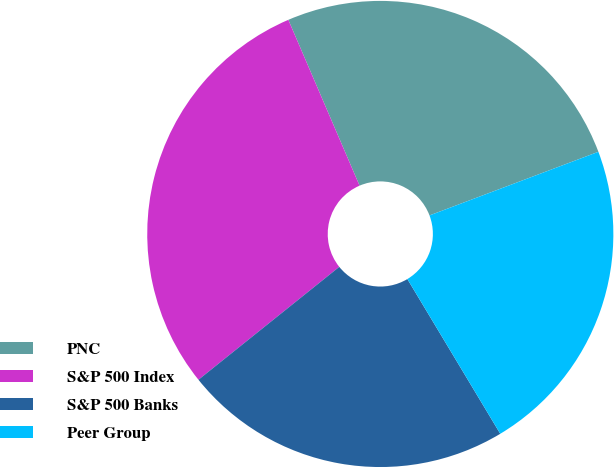Convert chart to OTSL. <chart><loc_0><loc_0><loc_500><loc_500><pie_chart><fcel>PNC<fcel>S&P 500 Index<fcel>S&P 500 Banks<fcel>Peer Group<nl><fcel>25.72%<fcel>29.3%<fcel>22.85%<fcel>22.13%<nl></chart> 